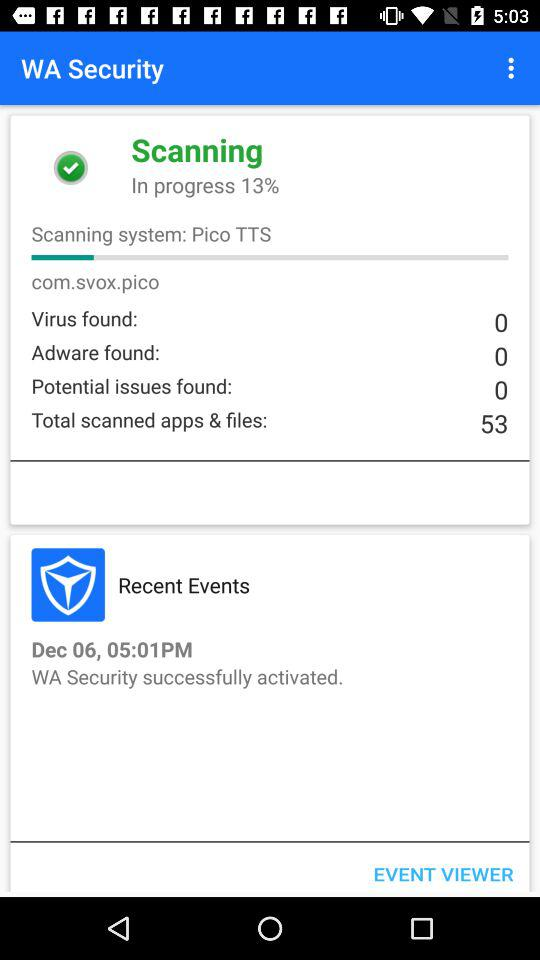What is the name of the scanning system? The name of the scanning system is Pico TTS. 